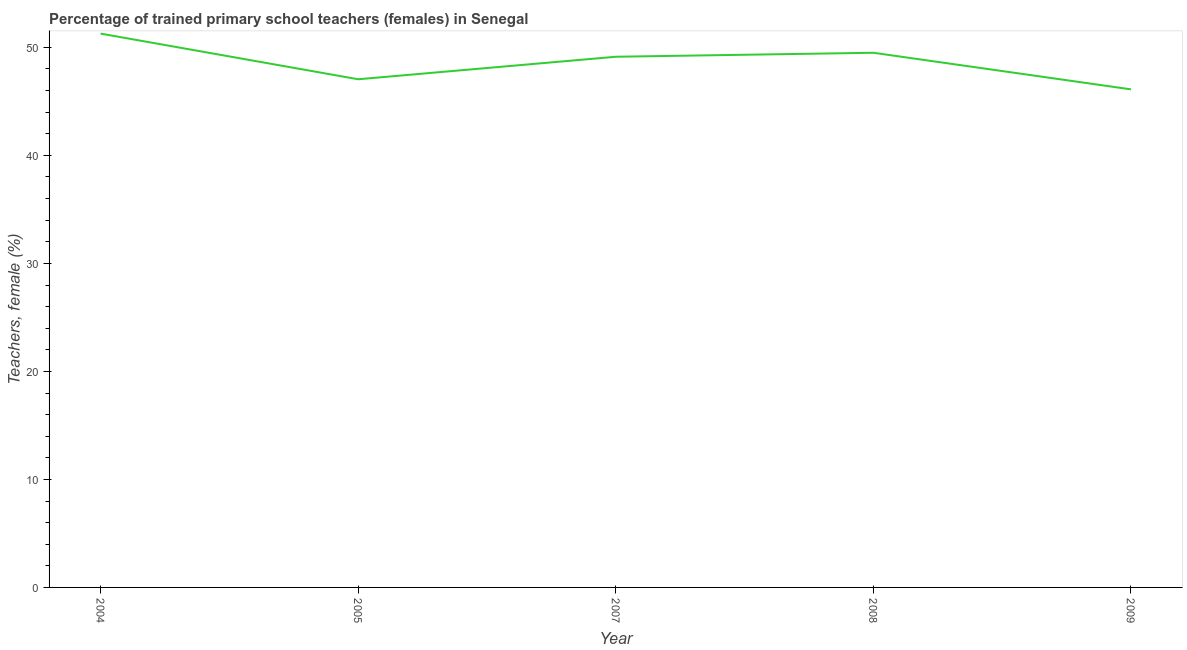What is the percentage of trained female teachers in 2009?
Ensure brevity in your answer.  46.11. Across all years, what is the maximum percentage of trained female teachers?
Make the answer very short. 51.28. Across all years, what is the minimum percentage of trained female teachers?
Your answer should be very brief. 46.11. In which year was the percentage of trained female teachers maximum?
Make the answer very short. 2004. In which year was the percentage of trained female teachers minimum?
Your answer should be compact. 2009. What is the sum of the percentage of trained female teachers?
Ensure brevity in your answer.  243.07. What is the difference between the percentage of trained female teachers in 2004 and 2007?
Your response must be concise. 2.14. What is the average percentage of trained female teachers per year?
Offer a terse response. 48.61. What is the median percentage of trained female teachers?
Offer a terse response. 49.13. Do a majority of the years between 2009 and 2007 (inclusive) have percentage of trained female teachers greater than 38 %?
Keep it short and to the point. No. What is the ratio of the percentage of trained female teachers in 2005 to that in 2007?
Your response must be concise. 0.96. Is the percentage of trained female teachers in 2008 less than that in 2009?
Provide a succinct answer. No. What is the difference between the highest and the second highest percentage of trained female teachers?
Your response must be concise. 1.77. What is the difference between the highest and the lowest percentage of trained female teachers?
Keep it short and to the point. 5.16. In how many years, is the percentage of trained female teachers greater than the average percentage of trained female teachers taken over all years?
Keep it short and to the point. 3. Does the percentage of trained female teachers monotonically increase over the years?
Provide a succinct answer. No. How many lines are there?
Your response must be concise. 1. What is the difference between two consecutive major ticks on the Y-axis?
Offer a terse response. 10. Are the values on the major ticks of Y-axis written in scientific E-notation?
Give a very brief answer. No. Does the graph contain any zero values?
Your response must be concise. No. What is the title of the graph?
Offer a terse response. Percentage of trained primary school teachers (females) in Senegal. What is the label or title of the Y-axis?
Keep it short and to the point. Teachers, female (%). What is the Teachers, female (%) in 2004?
Provide a short and direct response. 51.28. What is the Teachers, female (%) of 2005?
Your answer should be very brief. 47.05. What is the Teachers, female (%) in 2007?
Offer a terse response. 49.13. What is the Teachers, female (%) in 2008?
Your response must be concise. 49.5. What is the Teachers, female (%) of 2009?
Make the answer very short. 46.11. What is the difference between the Teachers, female (%) in 2004 and 2005?
Your answer should be very brief. 4.23. What is the difference between the Teachers, female (%) in 2004 and 2007?
Your answer should be very brief. 2.14. What is the difference between the Teachers, female (%) in 2004 and 2008?
Give a very brief answer. 1.77. What is the difference between the Teachers, female (%) in 2004 and 2009?
Provide a short and direct response. 5.16. What is the difference between the Teachers, female (%) in 2005 and 2007?
Provide a succinct answer. -2.08. What is the difference between the Teachers, female (%) in 2005 and 2008?
Your answer should be compact. -2.45. What is the difference between the Teachers, female (%) in 2005 and 2009?
Give a very brief answer. 0.93. What is the difference between the Teachers, female (%) in 2007 and 2008?
Offer a very short reply. -0.37. What is the difference between the Teachers, female (%) in 2007 and 2009?
Your response must be concise. 3.02. What is the difference between the Teachers, female (%) in 2008 and 2009?
Your answer should be very brief. 3.39. What is the ratio of the Teachers, female (%) in 2004 to that in 2005?
Your answer should be very brief. 1.09. What is the ratio of the Teachers, female (%) in 2004 to that in 2007?
Keep it short and to the point. 1.04. What is the ratio of the Teachers, female (%) in 2004 to that in 2008?
Offer a terse response. 1.04. What is the ratio of the Teachers, female (%) in 2004 to that in 2009?
Offer a terse response. 1.11. What is the ratio of the Teachers, female (%) in 2005 to that in 2007?
Offer a terse response. 0.96. What is the ratio of the Teachers, female (%) in 2005 to that in 2008?
Offer a terse response. 0.95. What is the ratio of the Teachers, female (%) in 2005 to that in 2009?
Ensure brevity in your answer.  1.02. What is the ratio of the Teachers, female (%) in 2007 to that in 2009?
Provide a short and direct response. 1.06. What is the ratio of the Teachers, female (%) in 2008 to that in 2009?
Offer a terse response. 1.07. 